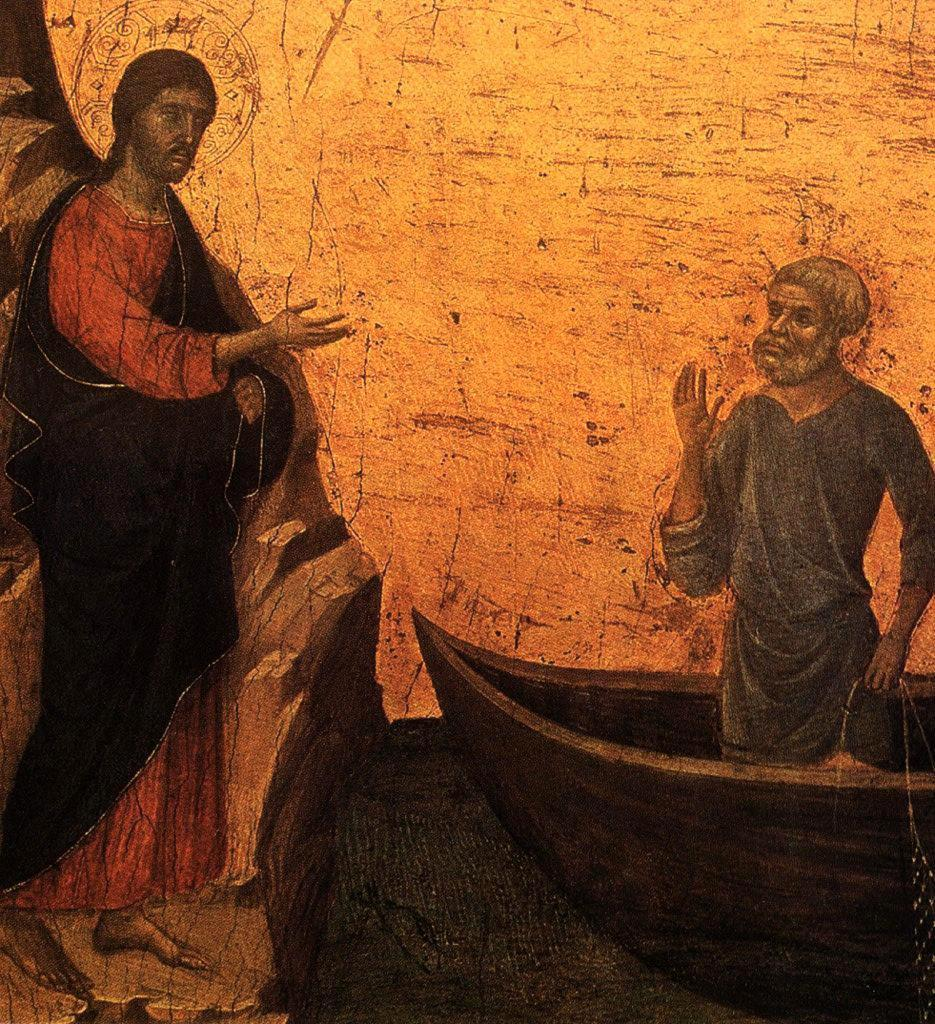What is depicted in the image? There is a sketch of two persons in the image. Can you describe the positions of the two persons? One person is standing on a board, while the other person is on the land. What color is the background of the image? The background of the image is in yellow color. How many frogs are jumping in the image? There are no frogs present in the image; it features a sketch of two persons. What type of ghost is visible in the image? There is no ghost present in the image; it is a sketch of two persons with no supernatural elements. 